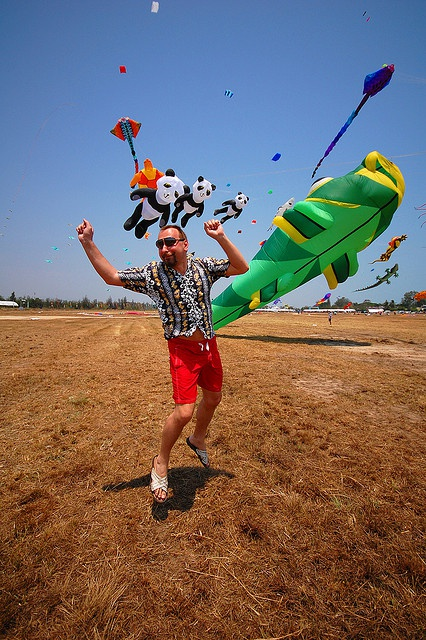Describe the objects in this image and their specific colors. I can see kite in blue, darkgreen, green, and black tones, people in blue, maroon, black, and gray tones, kite in blue, black, lavender, and darkgray tones, kite in blue, black, lavender, darkgray, and gray tones, and kite in blue, navy, black, darkblue, and darkgray tones in this image. 